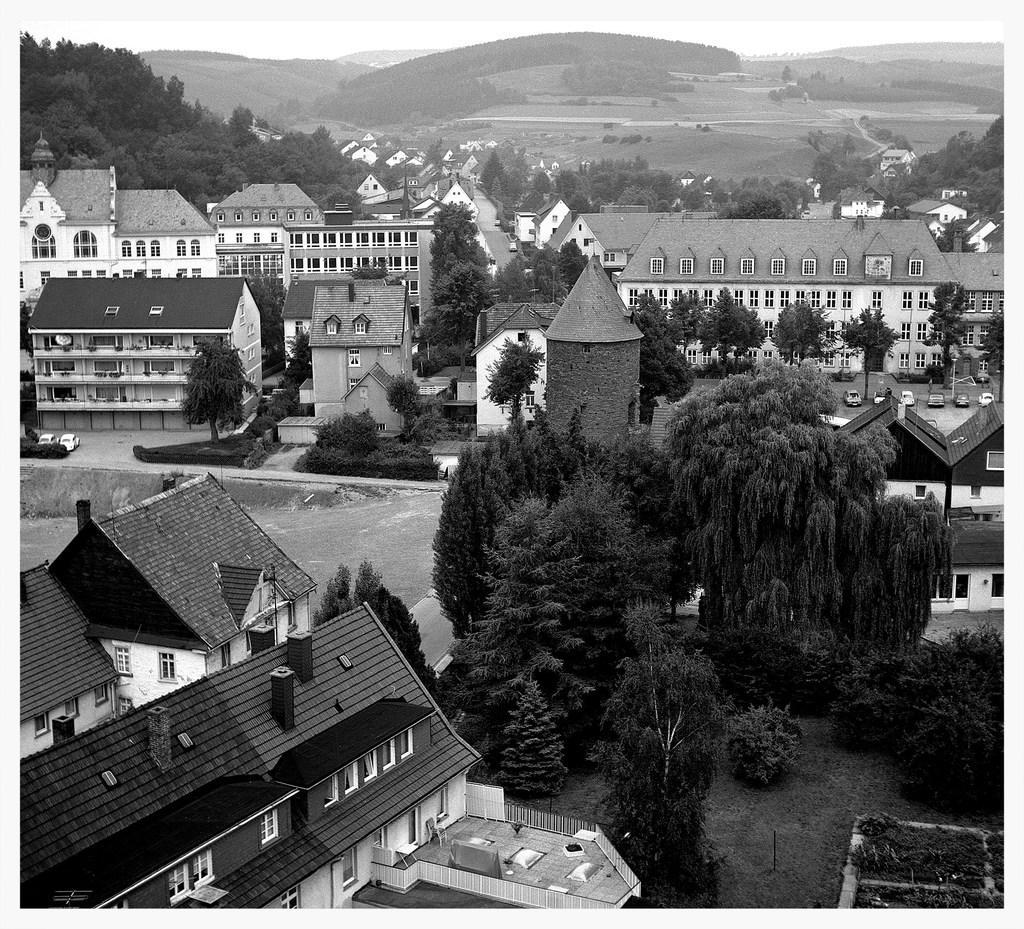Could you give a brief overview of what you see in this image? This is a black and white picture. Here we can see buildings, trees, plants, grass, vehicles, ground, and sky. 